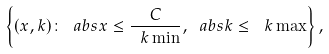<formula> <loc_0><loc_0><loc_500><loc_500>\left \{ ( x , k ) \colon \ a b s { x } \leq \frac { C } { \ k \min } , \ a b s { k } \leq \ k \max \right \} ,</formula> 